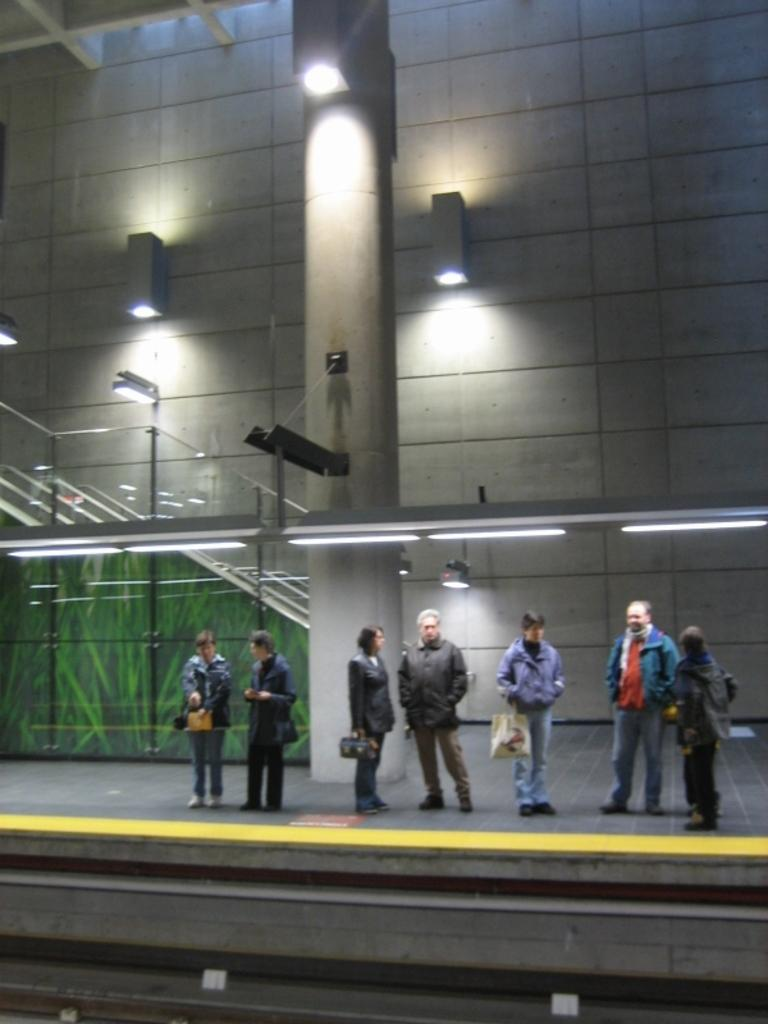What is illuminated by the lights in the image? The lights on the wall and pillar illuminate the area in the image. What are the people in the image doing? The people in the image are holding bags and wearing jackets. Can you describe the clothing of the people in the image? The people are wearing jackets. What advice does the queen give to the people in the image? There is no queen present in the image, so it is not possible to answer that question. 